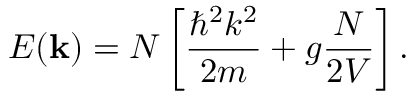<formula> <loc_0><loc_0><loc_500><loc_500>E ( k ) = N \left [ { \frac { \hbar { ^ } { 2 } k ^ { 2 } } { 2 m } } + g { \frac { N } { 2 V } } \right ] .</formula> 